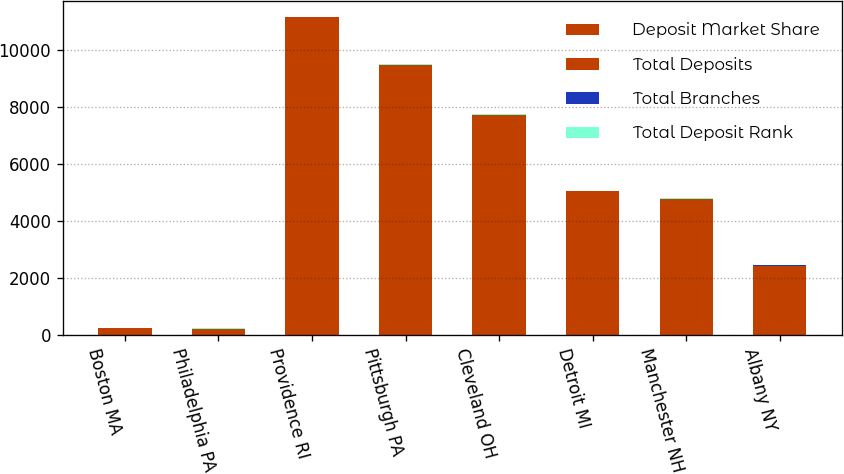Convert chart to OTSL. <chart><loc_0><loc_0><loc_500><loc_500><stacked_bar_chart><ecel><fcel>Boston MA<fcel>Philadelphia PA<fcel>Providence RI<fcel>Pittsburgh PA<fcel>Cleveland OH<fcel>Detroit MI<fcel>Manchester NH<fcel>Albany NY<nl><fcel>Deposit Market Share<fcel>204<fcel>180<fcel>99<fcel>123<fcel>55<fcel>90<fcel>22<fcel>24<nl><fcel>Total Deposits<fcel>23<fcel>23<fcel>11050<fcel>9362<fcel>7667<fcel>4959<fcel>4733<fcel>2401<nl><fcel>Total Branches<fcel>2<fcel>5<fcel>1<fcel>2<fcel>4<fcel>8<fcel>1<fcel>3<nl><fcel>Total Deposit Rank<fcel>15.1<fcel>4.9<fcel>28.8<fcel>8.9<fcel>12<fcel>4.1<fcel>42.5<fcel>14.4<nl></chart> 